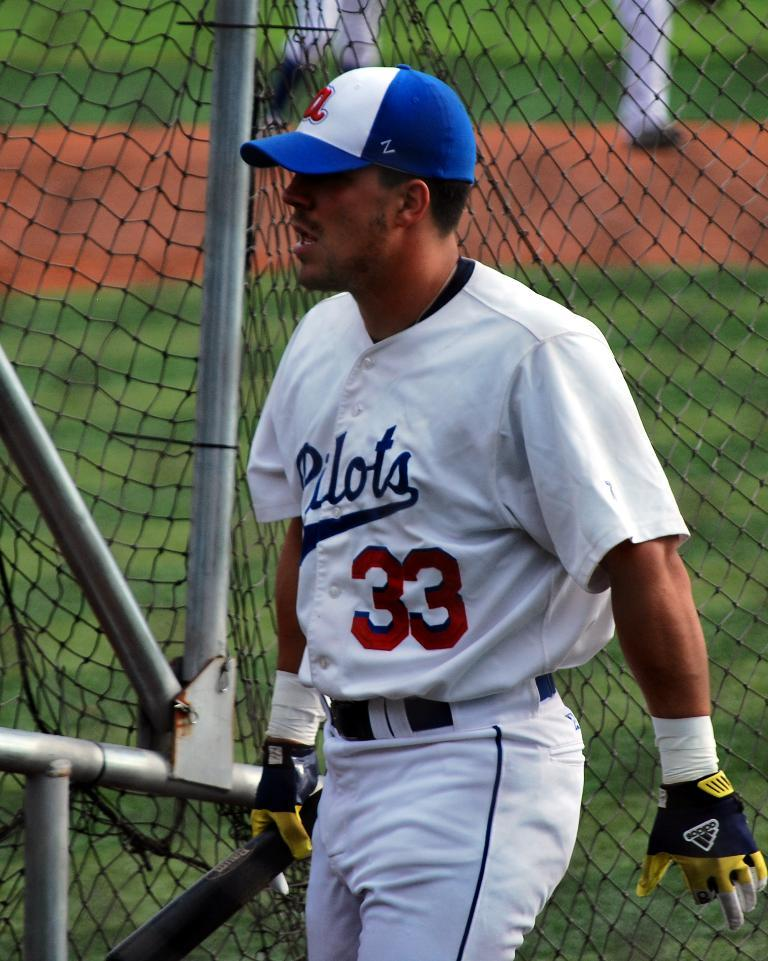<image>
Give a short and clear explanation of the subsequent image. Player number 33 on the pilots stands near some black mesh fencing. 